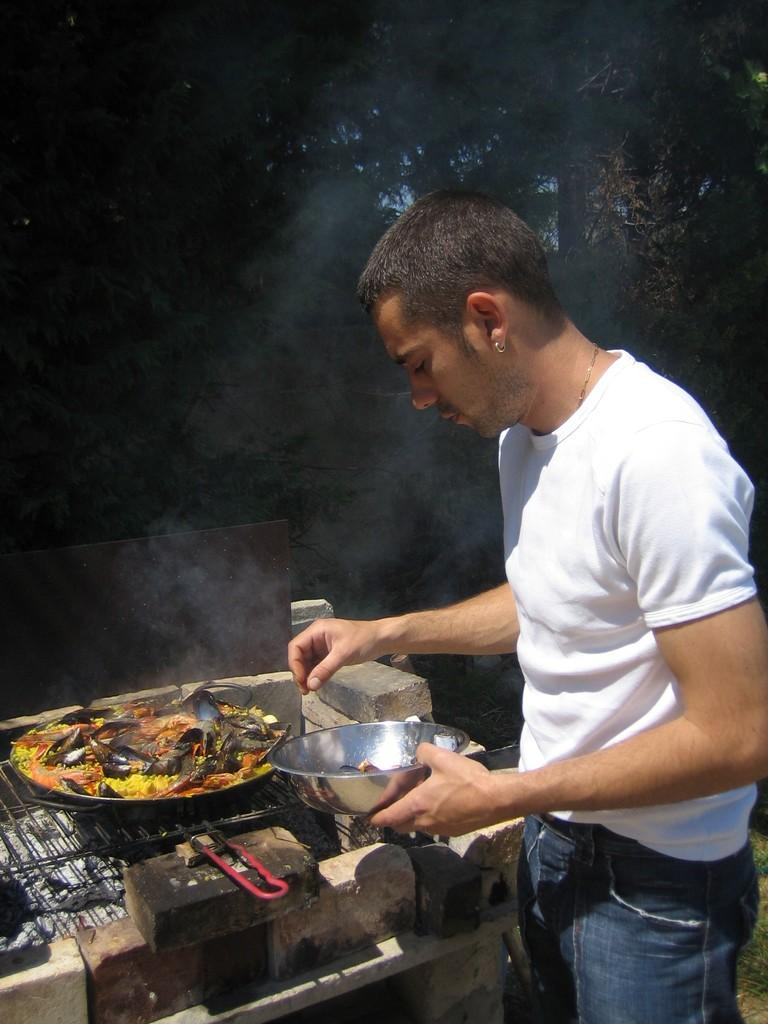What is the person in the image wearing on their upper body? The person is wearing a white shirt. What color are the pants the person is wearing? The person is wearing blue pants. What is in front of the person in the image? There is food in a pan in front of the person. What can be seen in the background of the image? Trees and the blue sky are visible in the background of the image. What type of scarf is the person wearing around their leg in the image? There is no scarf present in the image, and the person is not wearing anything around their leg. 